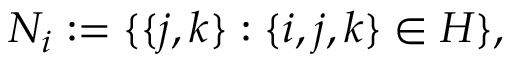Convert formula to latex. <formula><loc_0><loc_0><loc_500><loc_500>N _ { i } \colon = \{ \{ j , k \} \colon \{ i , j , k \} \in H \} ,</formula> 